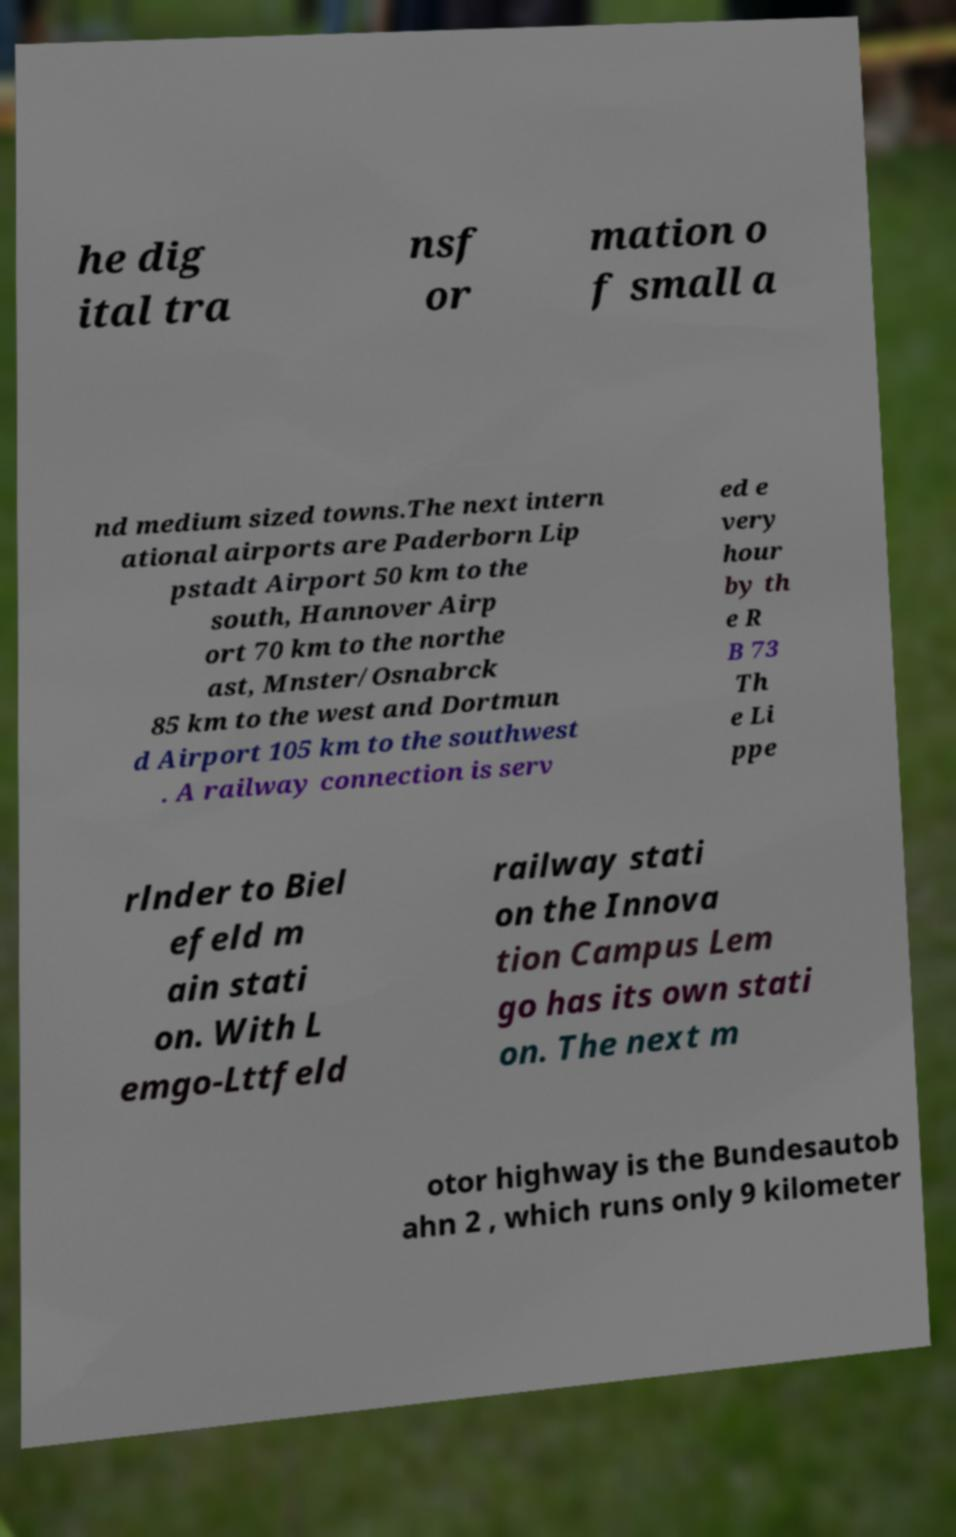Please read and relay the text visible in this image. What does it say? he dig ital tra nsf or mation o f small a nd medium sized towns.The next intern ational airports are Paderborn Lip pstadt Airport 50 km to the south, Hannover Airp ort 70 km to the northe ast, Mnster/Osnabrck 85 km to the west and Dortmun d Airport 105 km to the southwest . A railway connection is serv ed e very hour by th e R B 73 Th e Li ppe rlnder to Biel efeld m ain stati on. With L emgo-Lttfeld railway stati on the Innova tion Campus Lem go has its own stati on. The next m otor highway is the Bundesautob ahn 2 , which runs only 9 kilometer 